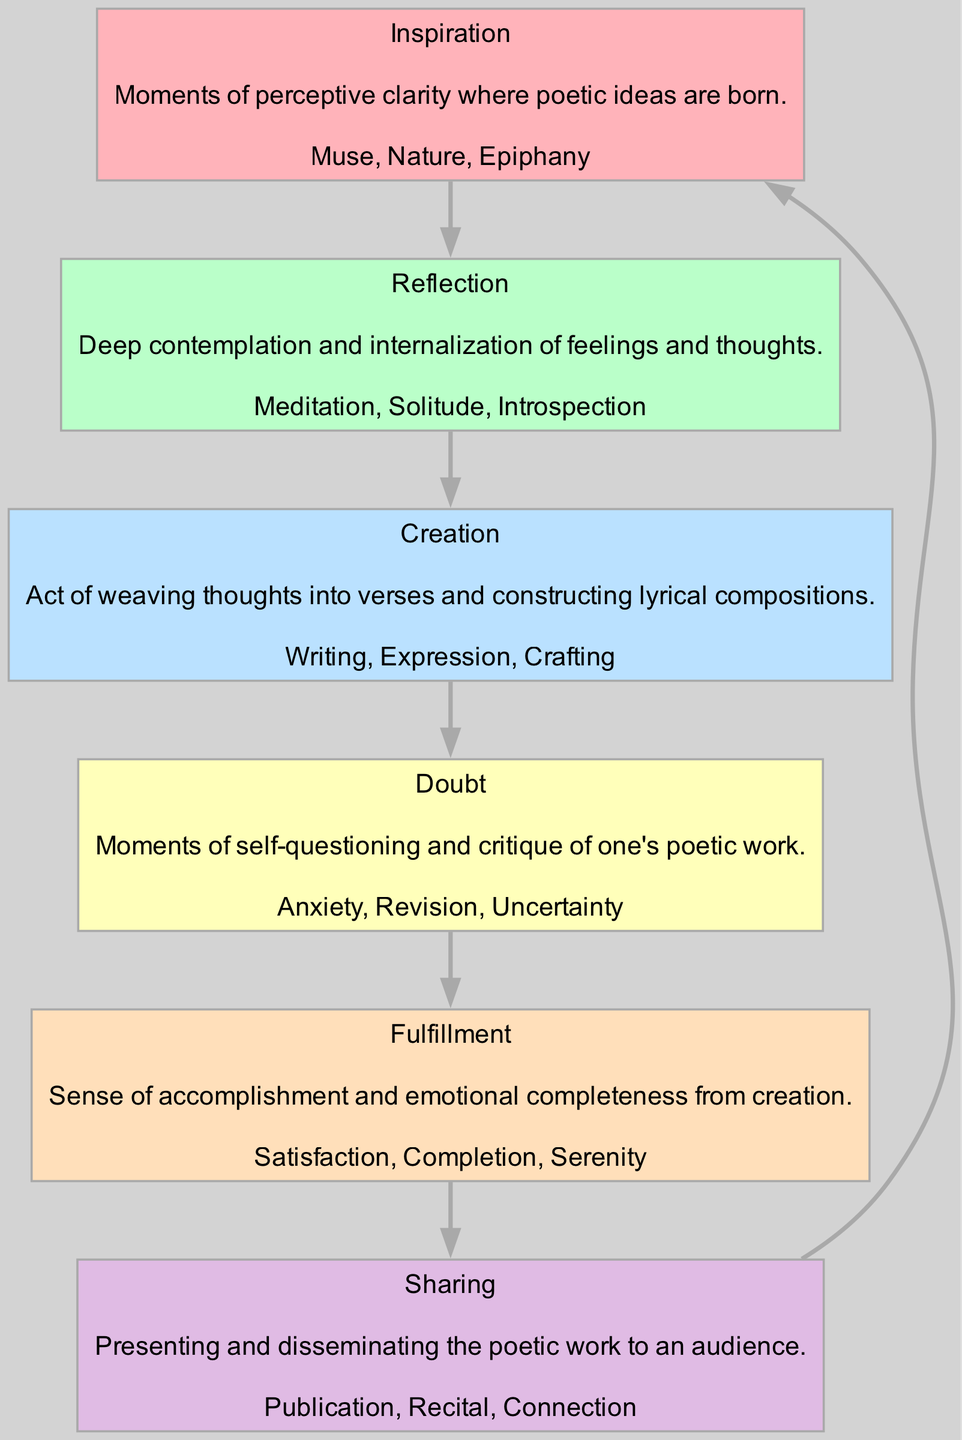What is the first phase in the emotional journey of a poet? The first phase is indicated in the diagram, which starts with "Inspiration." This phase is positioned at the top of the flow, clearly marked as the beginning of the emotional journey.
Answer: Inspiration How many phases are depicted in the diagram? The diagram includes six distinct phases, as each phase is represented by a separate node connected in sequence. This is easily counted by examining the diagram elements.
Answer: 6 Which phase comes after "Reflection"? In the diagram, the phase following "Reflection" is "Creation." This can be traced directly by following the connecting edge from "Reflection" to "Creation."
Answer: Creation What are the keywords associated with the "Doubt" phase? The keywords for "Doubt" are listed within the node for that phase. They are "Anxiety, Revision, Uncertainty," which are explicitly shown.
Answer: Anxiety, Revision, Uncertainty What is the relationship between the "Fulfillment" phase and the "Sharing" phase? In the diagram, there is a direct edge connecting "Fulfillment" to "Sharing," indicating that "Sharing" follows "Fulfillment" in the emotional journey, representing a connection in the flow.
Answer: Fulfillment leads to Sharing What feeling is primarily associated with the "Creation" phase? The main feeling associated with "Creation" is "Expression," as it is one of the keywords highlighted in the node description, indicating a key aspect of that phase.
Answer: Expression How does the "Inspiration" phase relate to the "Doubt" phase? The relationship is not direct in terms of sequence, as they are separated by "Reflection" and "Creation." However, "Inspiration" indirectly influences "Doubt," as initial inspiration can lead to subsequent doubts during the creative process.
Answer: Indirect influence What does the "Sharing" phase result in according to the diagram? The "Sharing" phase results in "Connection," as stated in the keywords associated with that node, indicating the outcome of presenting poetic work to an audience.
Answer: Connection 